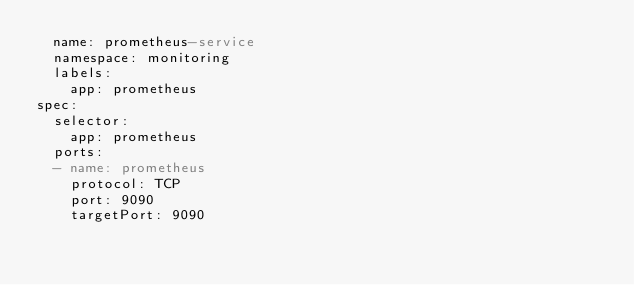<code> <loc_0><loc_0><loc_500><loc_500><_YAML_>  name: prometheus-service
  namespace: monitoring
  labels:
    app: prometheus
spec:
  selector:
    app: prometheus
  ports:
  - name: prometheus
    protocol: TCP
    port: 9090
    targetPort: 9090
</code> 